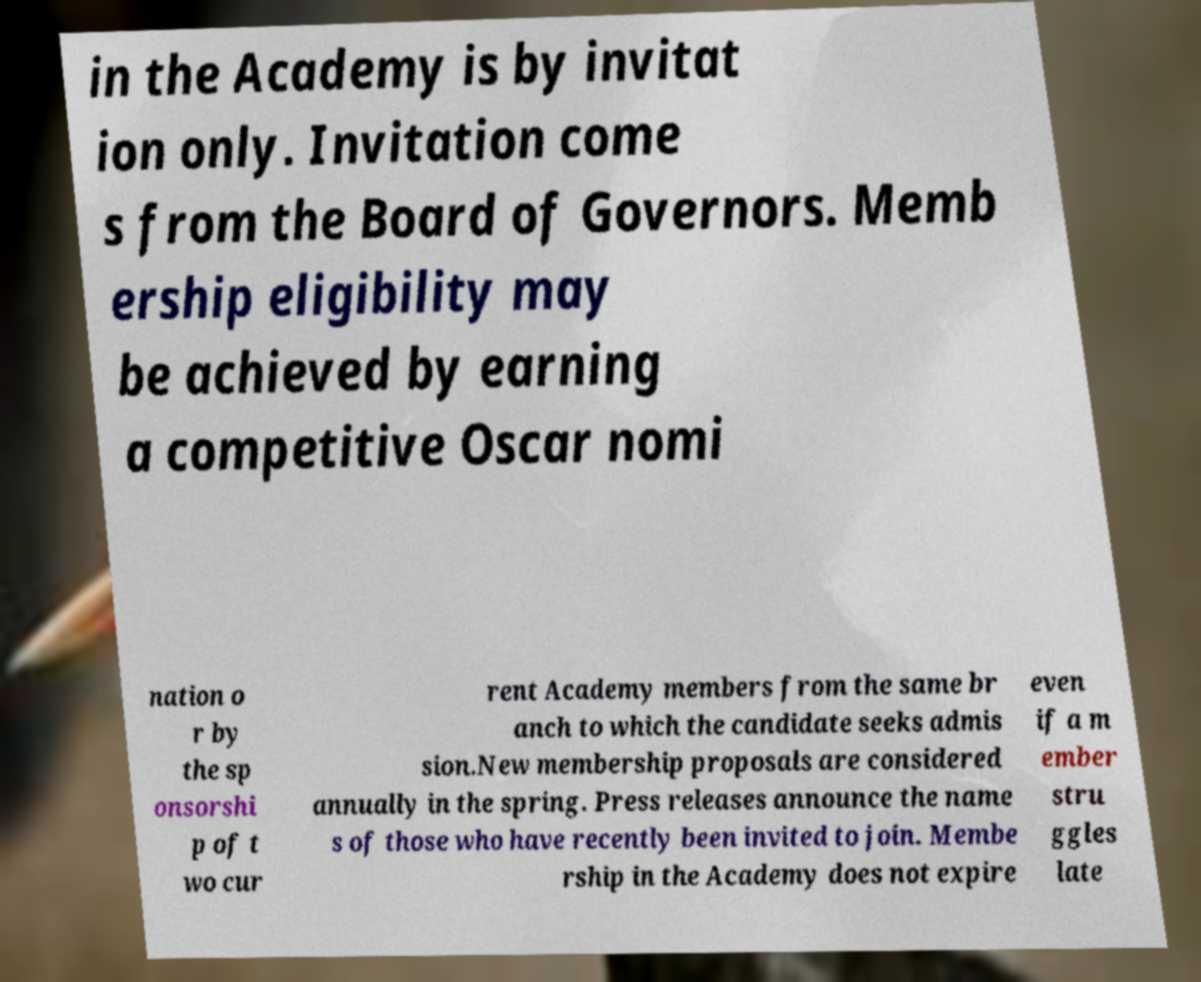Could you assist in decoding the text presented in this image and type it out clearly? in the Academy is by invitat ion only. Invitation come s from the Board of Governors. Memb ership eligibility may be achieved by earning a competitive Oscar nomi nation o r by the sp onsorshi p of t wo cur rent Academy members from the same br anch to which the candidate seeks admis sion.New membership proposals are considered annually in the spring. Press releases announce the name s of those who have recently been invited to join. Membe rship in the Academy does not expire even if a m ember stru ggles late 